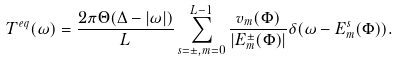<formula> <loc_0><loc_0><loc_500><loc_500>T ^ { e q } ( \omega ) = \frac { 2 \pi \Theta ( \Delta - | \omega | ) } { L } \sum _ { s = \pm , m = 0 } ^ { L - 1 } \frac { v _ { m } ( \Phi ) } { | E _ { m } ^ { \pm } ( \Phi ) | } \delta ( \omega - E ^ { s } _ { m } ( \Phi ) ) .</formula> 